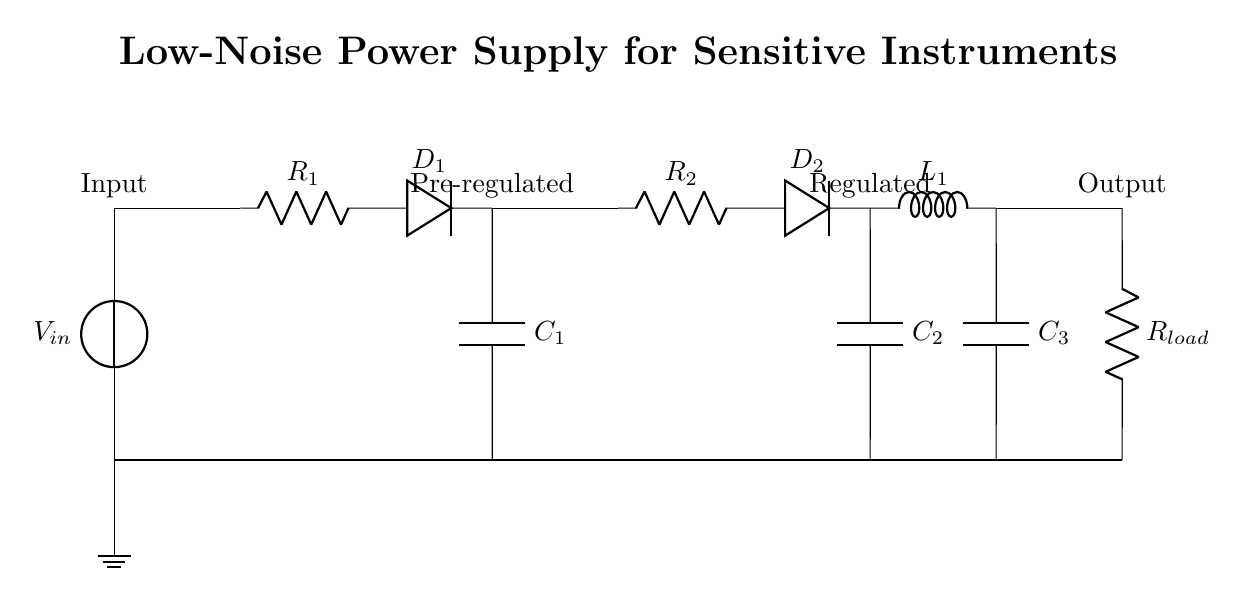What type of components are used in this circuit? The circuit consists of resistors, capacitors, diodes, and an inductor, as indicated by the symbols in the diagram.
Answer: Resistors, capacitors, diodes, inductor What is the role of D1 in this circuit? D1 is a diode that allows current to flow in one direction and provides protection against reverse polarity, ensuring that the voltage remains steady.
Answer: Rectification How many capacitors are present in the circuit? There are three capacitors labeled C1, C2, and C3, which are used for filtering and stabilizing the output voltage.
Answer: Three What is the position of the load in the circuit? The load is connected at the output and is represented by the resistor labeled R_load at the far right of the circuit diagram.
Answer: At the output What is the purpose of L1 in the circuit? L1 is an inductor that helps in reducing noise by opposing rapid changes in current, providing additional filtering for the output.
Answer: Noise reduction What is the voltage at the output section? The specific output voltage is not given in the diagram, but it is expected to be a regulated value lower than the input voltage, suitable for sensitive instruments.
Answer: Regulated What type of regulation method is used in this circuit? This circuit employs linear regulation methods, using series components (like resistors and diodes) to maintain a steady output voltage without introducing significant noise.
Answer: Linear regulation 